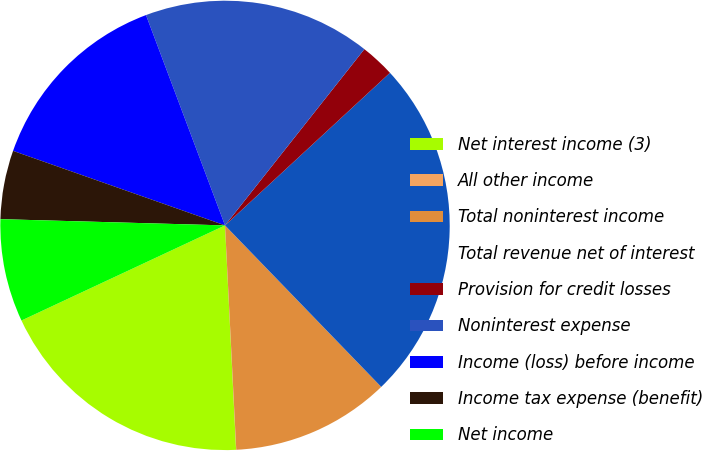Convert chart. <chart><loc_0><loc_0><loc_500><loc_500><pie_chart><fcel>Net interest income (3)<fcel>All other income<fcel>Total noninterest income<fcel>Total revenue net of interest<fcel>Provision for credit losses<fcel>Noninterest expense<fcel>Income (loss) before income<fcel>Income tax expense (benefit)<fcel>Net income<nl><fcel>18.83%<fcel>0.01%<fcel>11.44%<fcel>24.65%<fcel>2.47%<fcel>16.37%<fcel>13.9%<fcel>4.94%<fcel>7.4%<nl></chart> 